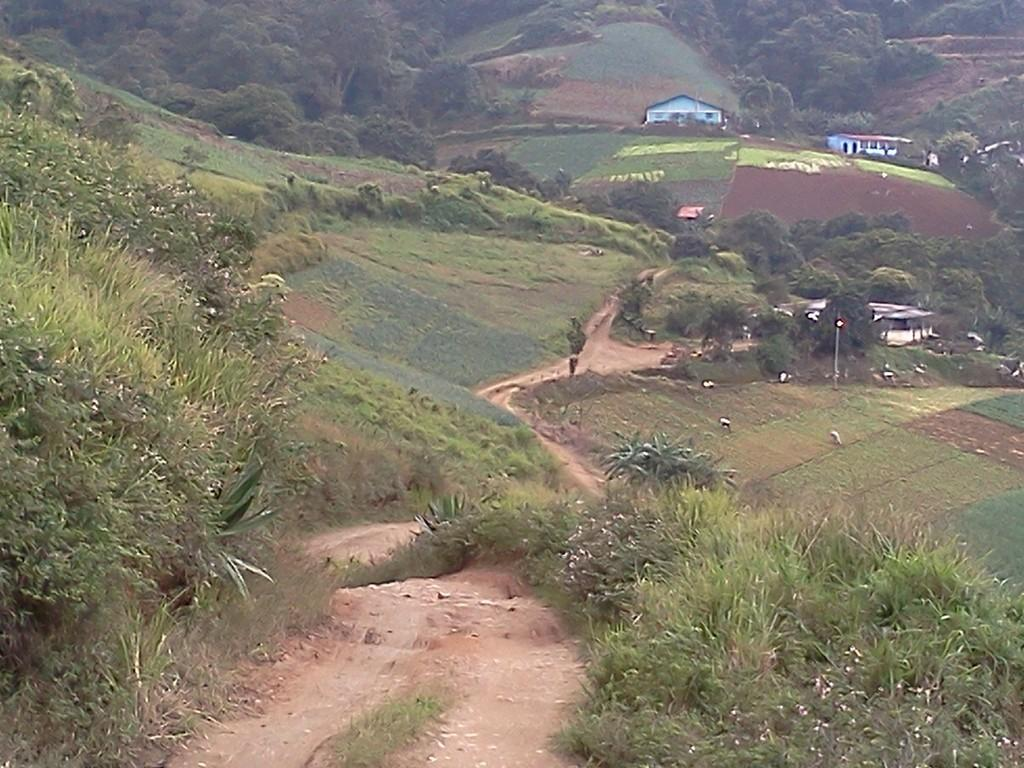What type of structures can be seen on the hills in the image? There are buildings on the hills in the image. What are the persons in the image doing? The persons in the image are standing on agricultural farms. What type of vegetation is present in the image? Shrubs, bushes, and trees are visible in the image. Can you see any fangs in the image? There are no fangs present in the image. What type of error can be seen in the image? There is no error visible in the image. 